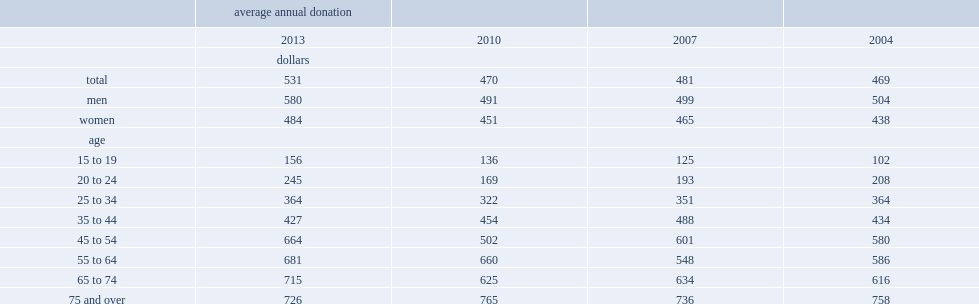How many dollars did donors aged 75 and over gave to non-profit or charitable organizations in 2013? 726.0. How many dollars were donors aged 75 and over gave to non-profit or charitable organizations more than donors aged 35 to 44? 299. 